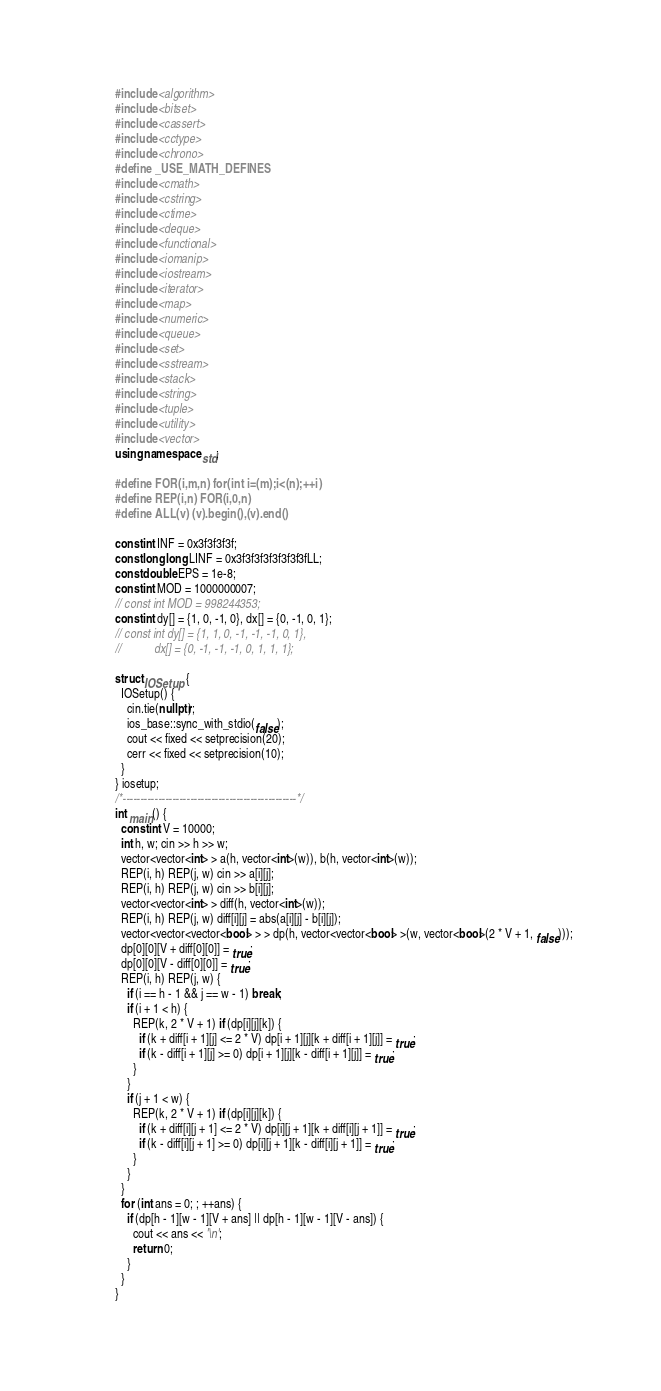Convert code to text. <code><loc_0><loc_0><loc_500><loc_500><_C++_>#include <algorithm>
#include <bitset>
#include <cassert>
#include <cctype>
#include <chrono>
#define _USE_MATH_DEFINES
#include <cmath>
#include <cstring>
#include <ctime>
#include <deque>
#include <functional>
#include <iomanip>
#include <iostream>
#include <iterator>
#include <map>
#include <numeric>
#include <queue>
#include <set>
#include <sstream>
#include <stack>
#include <string>
#include <tuple>
#include <utility>
#include <vector>
using namespace std;

#define FOR(i,m,n) for(int i=(m);i<(n);++i)
#define REP(i,n) FOR(i,0,n)
#define ALL(v) (v).begin(),(v).end()

const int INF = 0x3f3f3f3f;
const long long LINF = 0x3f3f3f3f3f3f3f3fLL;
const double EPS = 1e-8;
const int MOD = 1000000007;
// const int MOD = 998244353;
const int dy[] = {1, 0, -1, 0}, dx[] = {0, -1, 0, 1};
// const int dy[] = {1, 1, 0, -1, -1, -1, 0, 1},
//           dx[] = {0, -1, -1, -1, 0, 1, 1, 1};

struct IOSetup {
  IOSetup() {
    cin.tie(nullptr);
    ios_base::sync_with_stdio(false);
    cout << fixed << setprecision(20);
    cerr << fixed << setprecision(10);
  }
} iosetup;
/*-------------------------------------------------*/
int main() {
  const int V = 10000;
  int h, w; cin >> h >> w;
  vector<vector<int> > a(h, vector<int>(w)), b(h, vector<int>(w));
  REP(i, h) REP(j, w) cin >> a[i][j];
  REP(i, h) REP(j, w) cin >> b[i][j];
  vector<vector<int> > diff(h, vector<int>(w));
  REP(i, h) REP(j, w) diff[i][j] = abs(a[i][j] - b[i][j]);
  vector<vector<vector<bool> > > dp(h, vector<vector<bool> >(w, vector<bool>(2 * V + 1, false)));
  dp[0][0][V + diff[0][0]] = true;
  dp[0][0][V - diff[0][0]] = true;
  REP(i, h) REP(j, w) {
    if (i == h - 1 && j == w - 1) break;
    if (i + 1 < h) {
      REP(k, 2 * V + 1) if (dp[i][j][k]) {
        if (k + diff[i + 1][j] <= 2 * V) dp[i + 1][j][k + diff[i + 1][j]] = true;
        if (k - diff[i + 1][j] >= 0) dp[i + 1][j][k - diff[i + 1][j]] = true;
      }
    }
    if (j + 1 < w) {
      REP(k, 2 * V + 1) if (dp[i][j][k]) {
        if (k + diff[i][j + 1] <= 2 * V) dp[i][j + 1][k + diff[i][j + 1]] = true;
        if (k - diff[i][j + 1] >= 0) dp[i][j + 1][k - diff[i][j + 1]] = true;
      }
    }
  }
  for (int ans = 0; ; ++ans) {
    if (dp[h - 1][w - 1][V + ans] || dp[h - 1][w - 1][V - ans]) {
      cout << ans << '\n';
      return 0;
    }
  }
}
</code> 